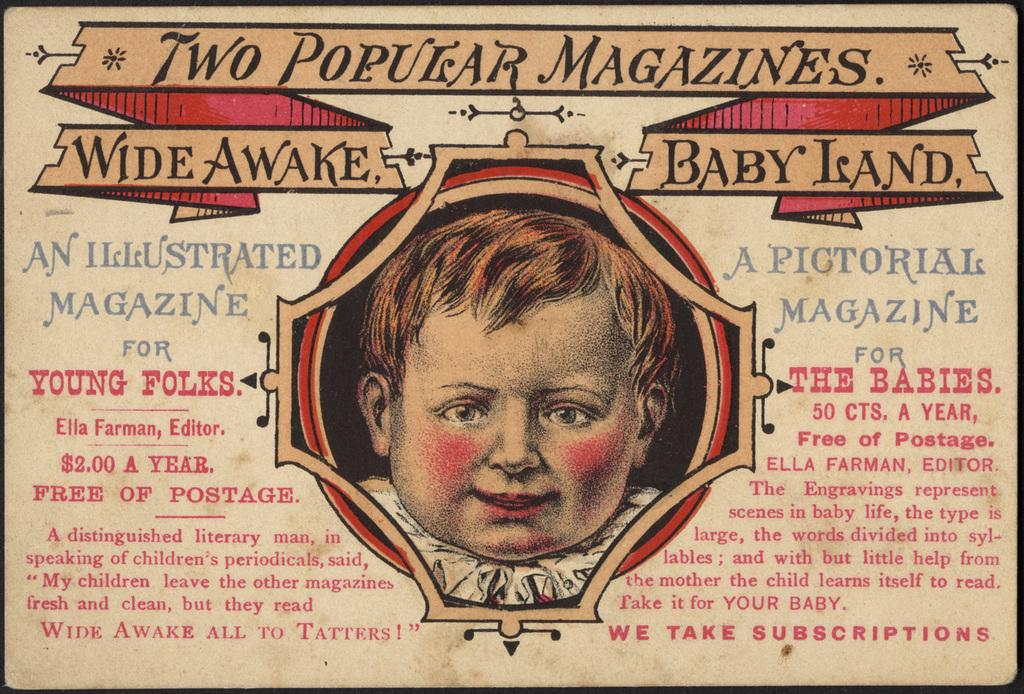What is featured in the image? There is a poster in the image. What can be seen on the poster? The poster contains a picture. What else is present on the poster besides the picture? There is text on the poster. What type of curtain is hanging in front of the poster in the image? There is no curtain present in the image; it only features a poster with a picture and text. How many hens are depicted on the poster? There are no hens present on the poster; it contains a picture and text, but no animals. 